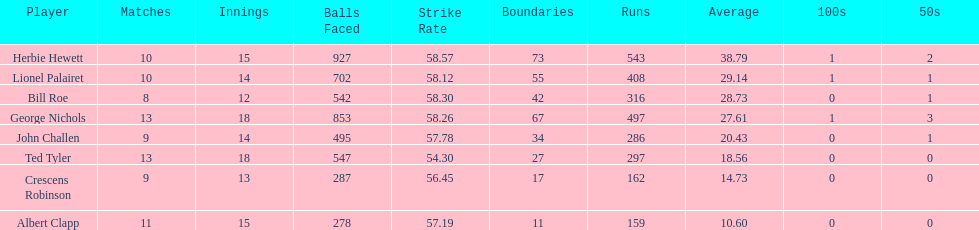Name a player that play in no more than 13 innings. Bill Roe. 